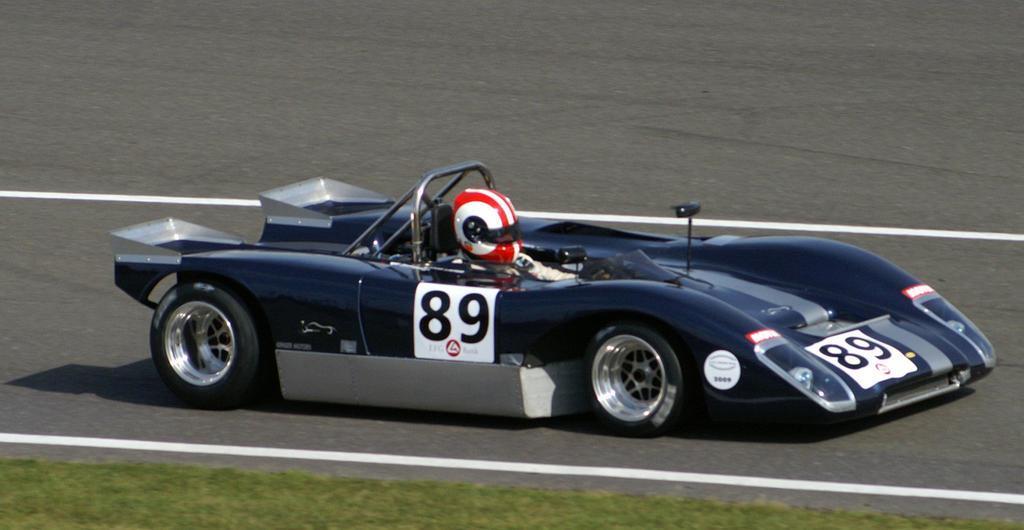How would you summarize this image in a sentence or two? In this image we can see one man with red helmet, driving a car on the road and some green grass on the surface. 